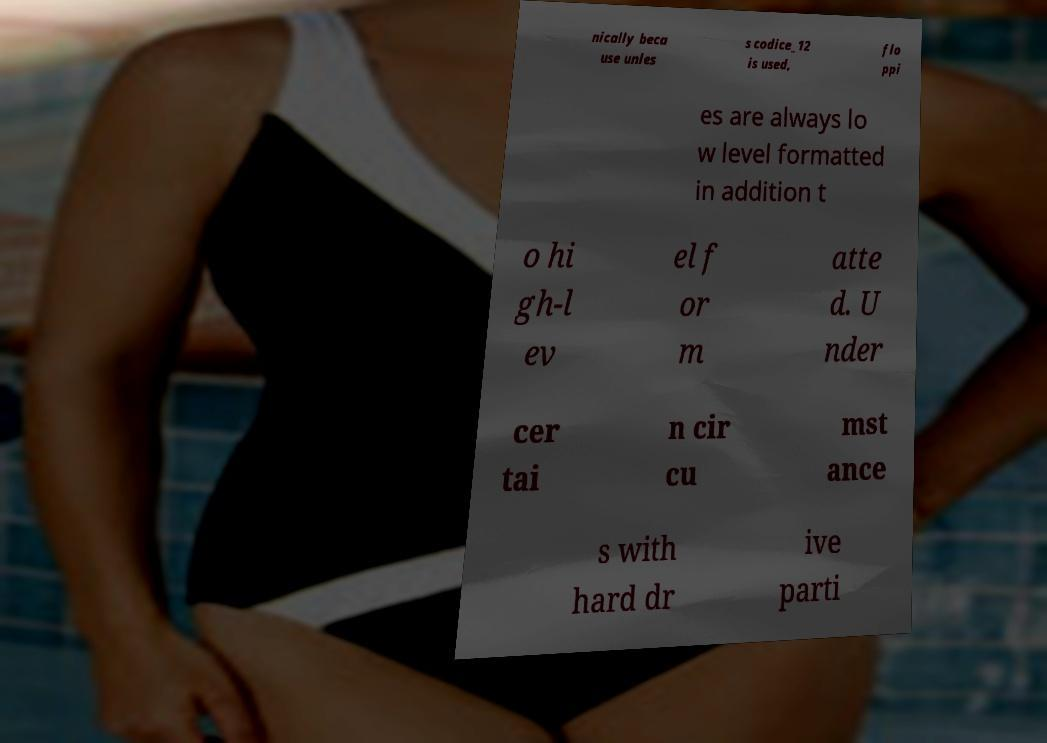Could you extract and type out the text from this image? nically beca use unles s codice_12 is used, flo ppi es are always lo w level formatted in addition t o hi gh-l ev el f or m atte d. U nder cer tai n cir cu mst ance s with hard dr ive parti 